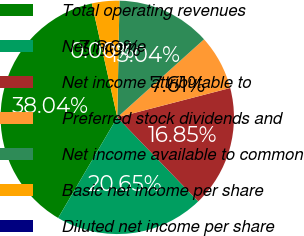Convert chart to OTSL. <chart><loc_0><loc_0><loc_500><loc_500><pie_chart><fcel>Total operating revenues<fcel>Net income<fcel>Net income attributable to<fcel>Preferred stock dividends and<fcel>Net income available to common<fcel>Basic net income per share<fcel>Diluted net income per share<nl><fcel>38.04%<fcel>20.65%<fcel>16.85%<fcel>7.61%<fcel>13.04%<fcel>3.8%<fcel>0.0%<nl></chart> 